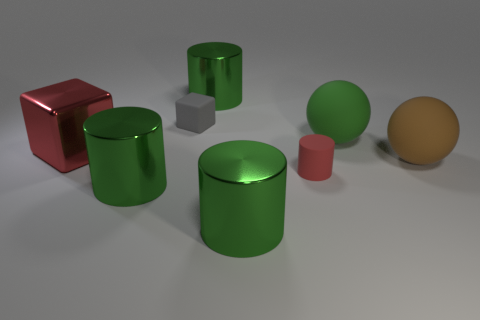Imagine this as a scene from a film. What genre might it represent and why? The clean, minimalist arrangement and the presence of geometric shapes might suggest a scene from a science fiction film, evoking images of a methodical and high-tech environment. The stark lighting and the assortment of objects could serve as a backdrop for a narrative involving innovation or exploration. 